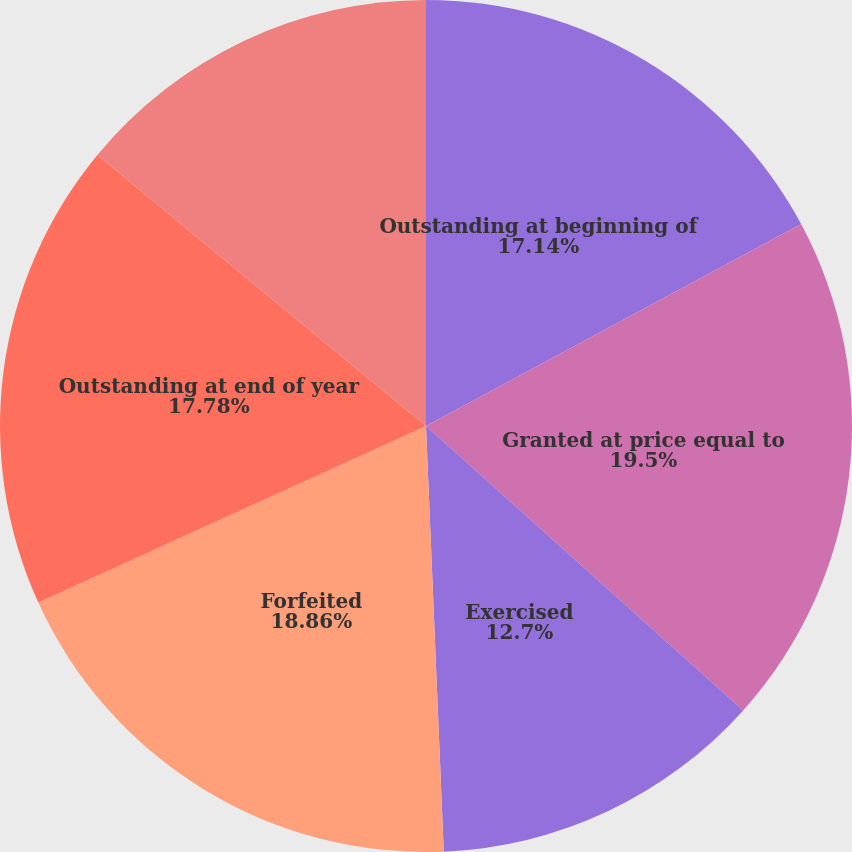<chart> <loc_0><loc_0><loc_500><loc_500><pie_chart><fcel>Outstanding at beginning of<fcel>Granted at price equal to<fcel>Exercised<fcel>Forfeited<fcel>Outstanding at end of year<fcel>Exercisable at end of year<nl><fcel>17.14%<fcel>19.49%<fcel>12.7%<fcel>18.86%<fcel>17.78%<fcel>14.02%<nl></chart> 